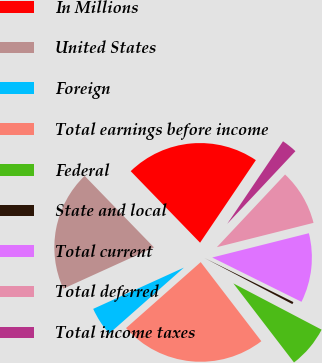Convert chart to OTSL. <chart><loc_0><loc_0><loc_500><loc_500><pie_chart><fcel>In Millions<fcel>United States<fcel>Foreign<fcel>Total earnings before income<fcel>Federal<fcel>State and local<fcel>Total current<fcel>Total deferred<fcel>Total income taxes<nl><fcel>21.71%<fcel>19.54%<fcel>4.72%<fcel>23.89%<fcel>6.9%<fcel>0.36%<fcel>11.25%<fcel>9.08%<fcel>2.54%<nl></chart> 